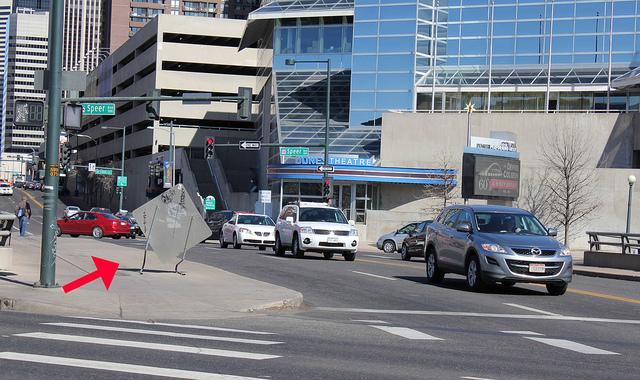What boulevard is the Jones Theater on? speer 